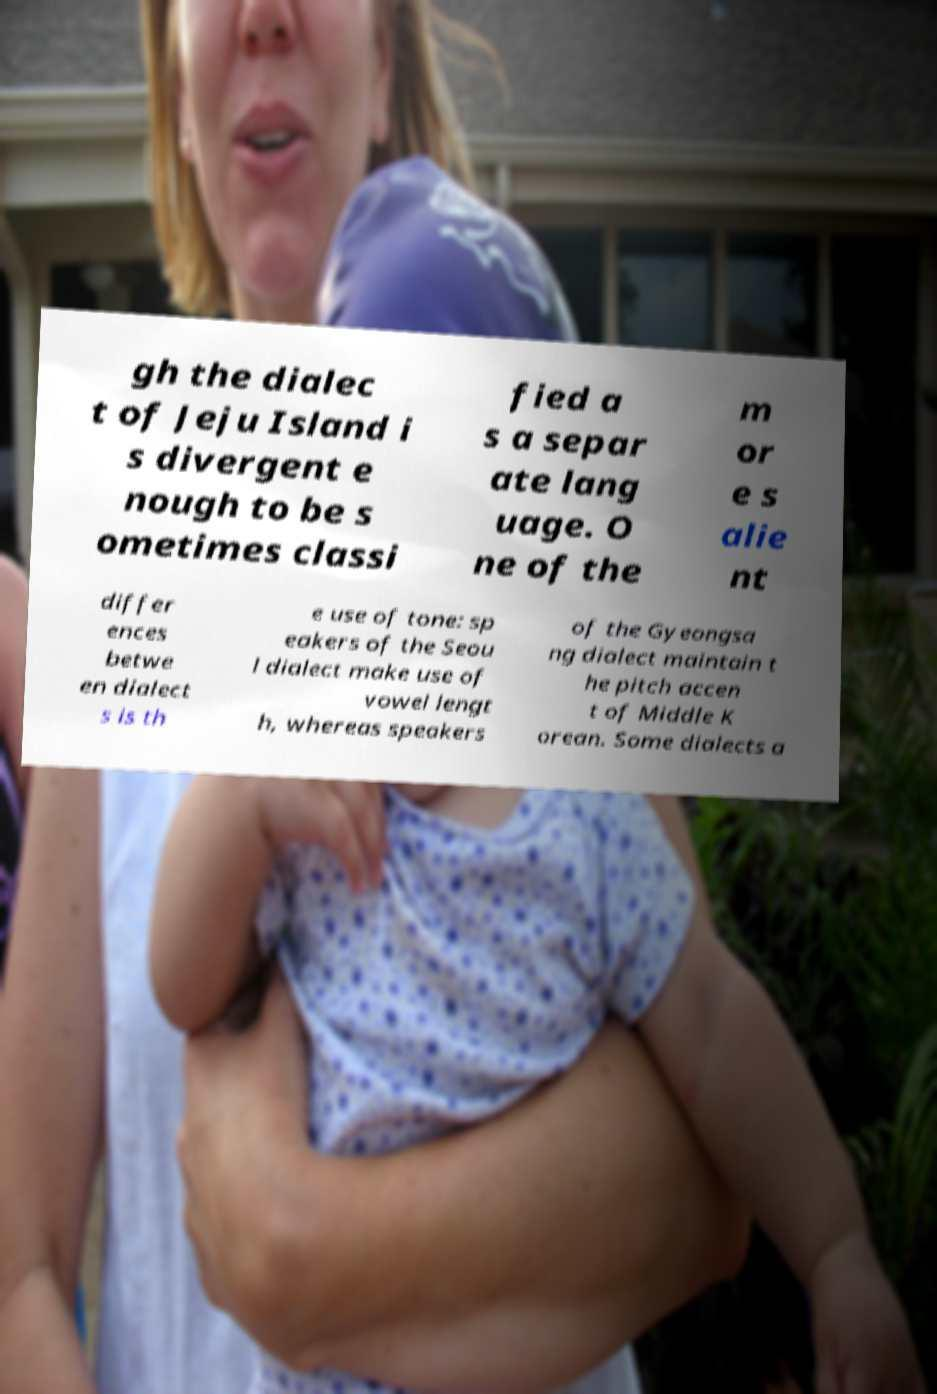Can you read and provide the text displayed in the image?This photo seems to have some interesting text. Can you extract and type it out for me? gh the dialec t of Jeju Island i s divergent e nough to be s ometimes classi fied a s a separ ate lang uage. O ne of the m or e s alie nt differ ences betwe en dialect s is th e use of tone: sp eakers of the Seou l dialect make use of vowel lengt h, whereas speakers of the Gyeongsa ng dialect maintain t he pitch accen t of Middle K orean. Some dialects a 